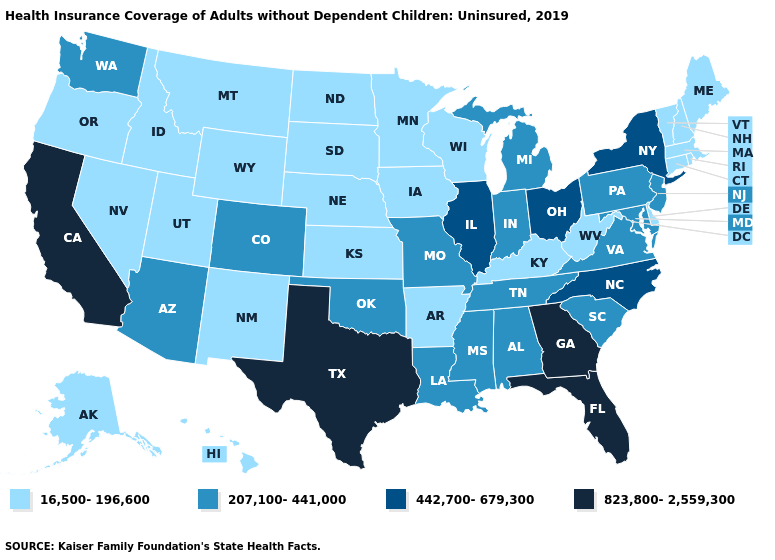What is the highest value in states that border Connecticut?
Short answer required. 442,700-679,300. What is the value of Louisiana?
Quick response, please. 207,100-441,000. Name the states that have a value in the range 442,700-679,300?
Give a very brief answer. Illinois, New York, North Carolina, Ohio. Does Massachusetts have the lowest value in the USA?
Write a very short answer. Yes. What is the value of Louisiana?
Give a very brief answer. 207,100-441,000. Does California have a higher value than Arizona?
Short answer required. Yes. Name the states that have a value in the range 207,100-441,000?
Give a very brief answer. Alabama, Arizona, Colorado, Indiana, Louisiana, Maryland, Michigan, Mississippi, Missouri, New Jersey, Oklahoma, Pennsylvania, South Carolina, Tennessee, Virginia, Washington. Does Alabama have a higher value than Tennessee?
Short answer required. No. Among the states that border Oklahoma , which have the highest value?
Concise answer only. Texas. Name the states that have a value in the range 16,500-196,600?
Write a very short answer. Alaska, Arkansas, Connecticut, Delaware, Hawaii, Idaho, Iowa, Kansas, Kentucky, Maine, Massachusetts, Minnesota, Montana, Nebraska, Nevada, New Hampshire, New Mexico, North Dakota, Oregon, Rhode Island, South Dakota, Utah, Vermont, West Virginia, Wisconsin, Wyoming. Which states have the lowest value in the USA?
Keep it brief. Alaska, Arkansas, Connecticut, Delaware, Hawaii, Idaho, Iowa, Kansas, Kentucky, Maine, Massachusetts, Minnesota, Montana, Nebraska, Nevada, New Hampshire, New Mexico, North Dakota, Oregon, Rhode Island, South Dakota, Utah, Vermont, West Virginia, Wisconsin, Wyoming. Name the states that have a value in the range 207,100-441,000?
Be succinct. Alabama, Arizona, Colorado, Indiana, Louisiana, Maryland, Michigan, Mississippi, Missouri, New Jersey, Oklahoma, Pennsylvania, South Carolina, Tennessee, Virginia, Washington. Name the states that have a value in the range 442,700-679,300?
Write a very short answer. Illinois, New York, North Carolina, Ohio. Name the states that have a value in the range 823,800-2,559,300?
Give a very brief answer. California, Florida, Georgia, Texas. Does Pennsylvania have the lowest value in the USA?
Write a very short answer. No. 